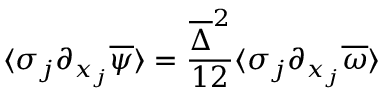<formula> <loc_0><loc_0><loc_500><loc_500>\langle \sigma _ { j } \partial _ { x _ { j } } \overline { \psi } \rangle = \frac { \overline { \Delta } ^ { 2 } } { 1 2 } \langle \sigma _ { j } \partial _ { x _ { j } } \overline { \omega } \rangle</formula> 